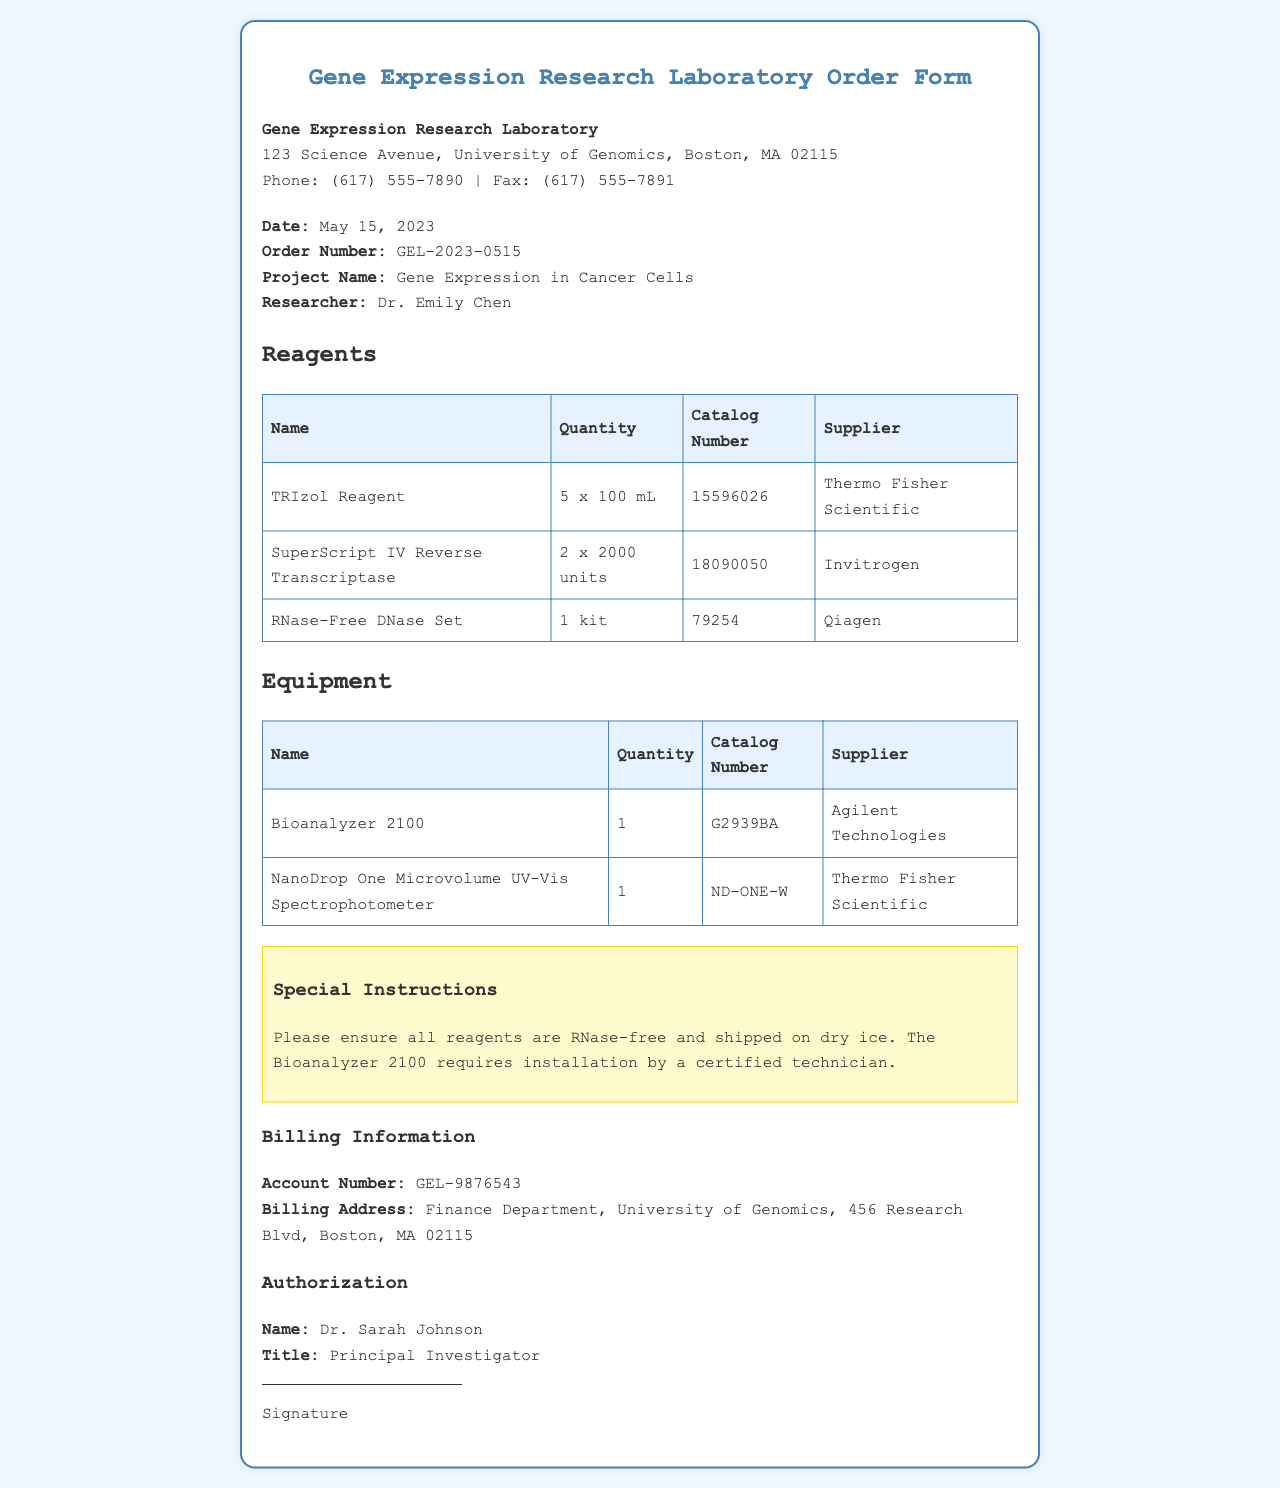What is the order number? The order number is specified in the order details section of the document.
Answer: GEL-2023-0515 Who is the researcher? The researcher's name is stated in the order details section.
Answer: Dr. Emily Chen What is the quantity of TRIzol Reagent ordered? The quantity can be found in the reagents table.
Answer: 5 x 100 mL What special instructions are provided? The special instructions section outlines specific handling and shipping requirements.
Answer: Please ensure all reagents are RNase-free and shipped on dry ice What is the billing account number? The billing account number is provided in the billing information section of the document.
Answer: GEL-9876543 How many pieces of equipment are listed? The total number of equipment items can be counted in the equipment table.
Answer: 2 What is the title of the authorized signer? The title is included in the authorization section under the name of the signer.
Answer: Principal Investigator What is the name of the supplier for the NanoDrop One Microvolume UV-Vis Spectrophotometer? The supplier's name is found in the equipment table next to the specific equipment.
Answer: Thermo Fisher Scientific Which laboratory conducts this gene expression research? The laboratory’s name is stated at the top of the document.
Answer: Gene Expression Research Laboratory 